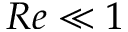<formula> <loc_0><loc_0><loc_500><loc_500>R e \ll 1</formula> 